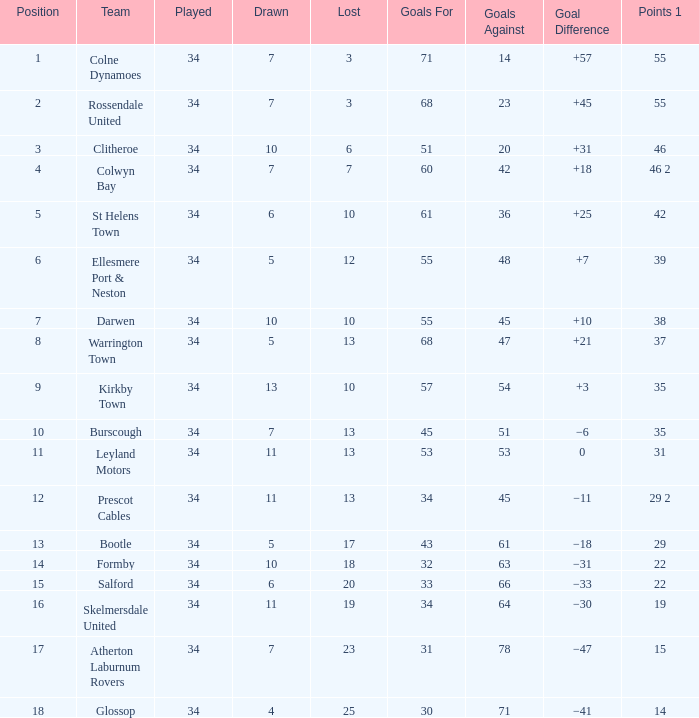Which goals for has a total of 12 and has been played more than 34 times? None. 